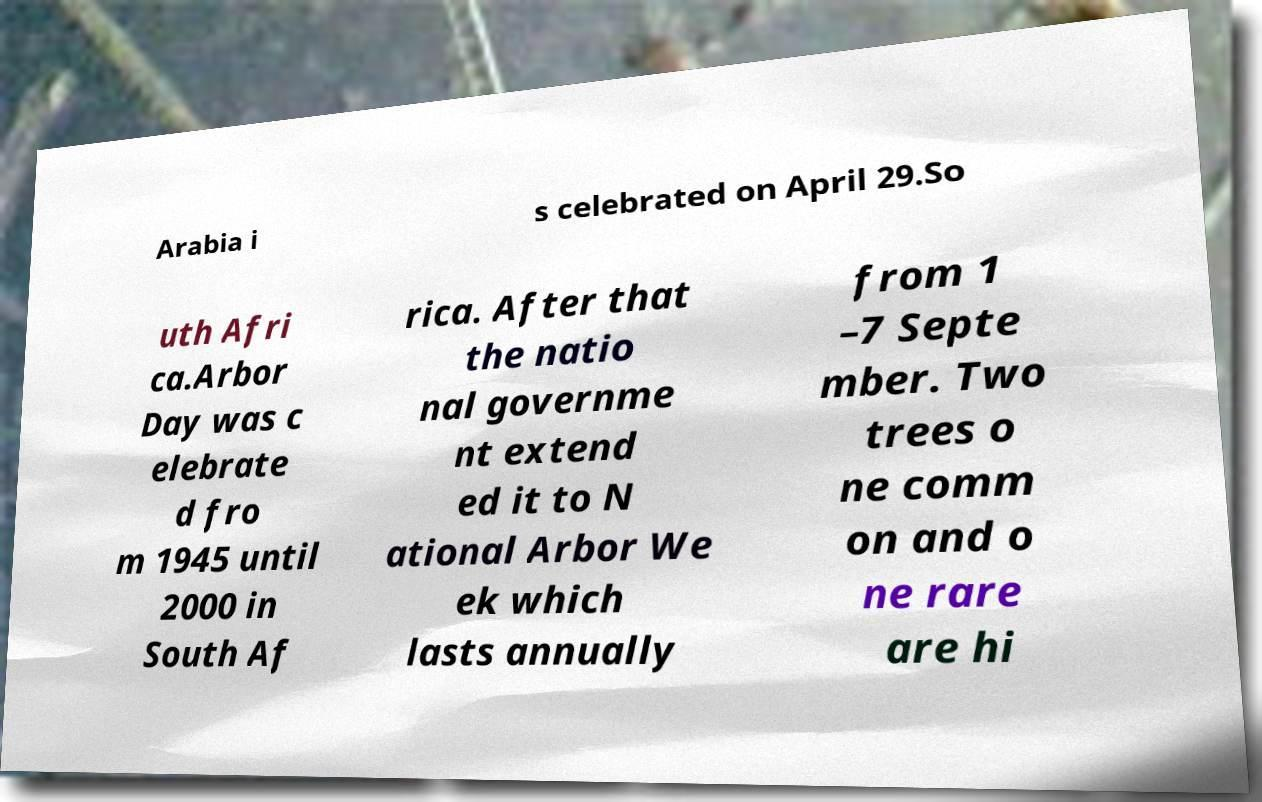What messages or text are displayed in this image? I need them in a readable, typed format. Arabia i s celebrated on April 29.So uth Afri ca.Arbor Day was c elebrate d fro m 1945 until 2000 in South Af rica. After that the natio nal governme nt extend ed it to N ational Arbor We ek which lasts annually from 1 –7 Septe mber. Two trees o ne comm on and o ne rare are hi 